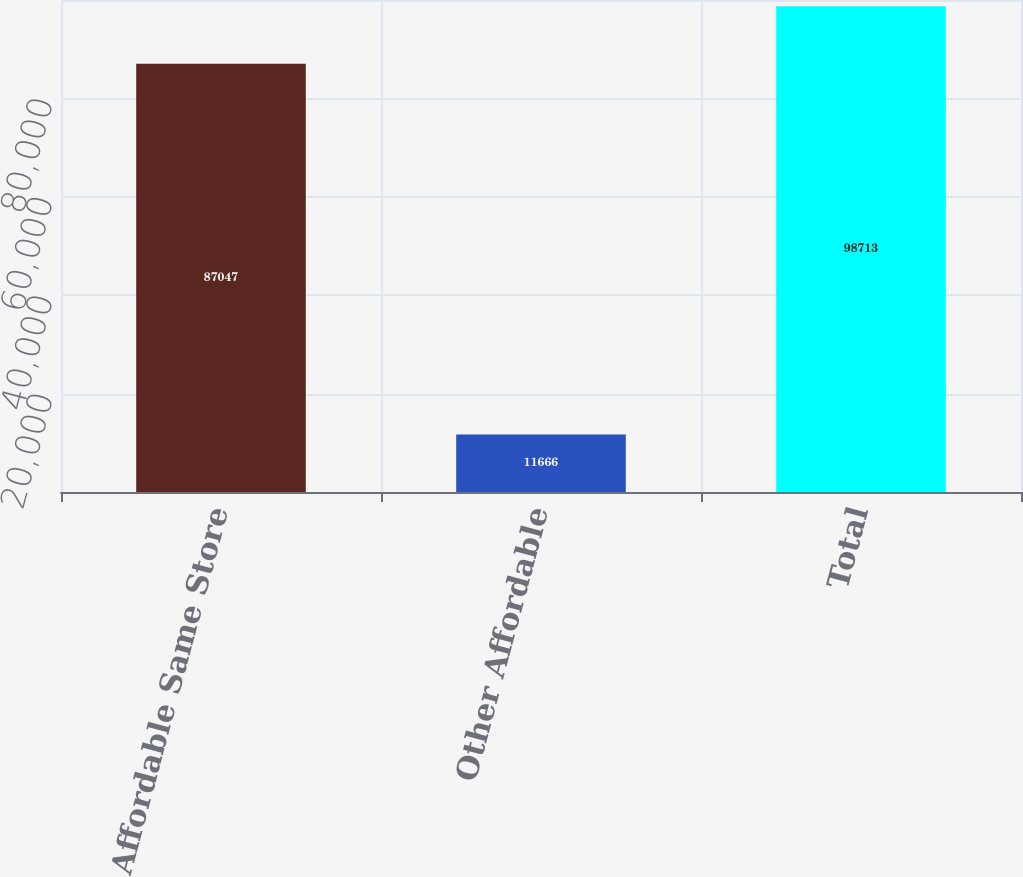Convert chart to OTSL. <chart><loc_0><loc_0><loc_500><loc_500><bar_chart><fcel>Affordable Same Store<fcel>Other Affordable<fcel>Total<nl><fcel>87047<fcel>11666<fcel>98713<nl></chart> 